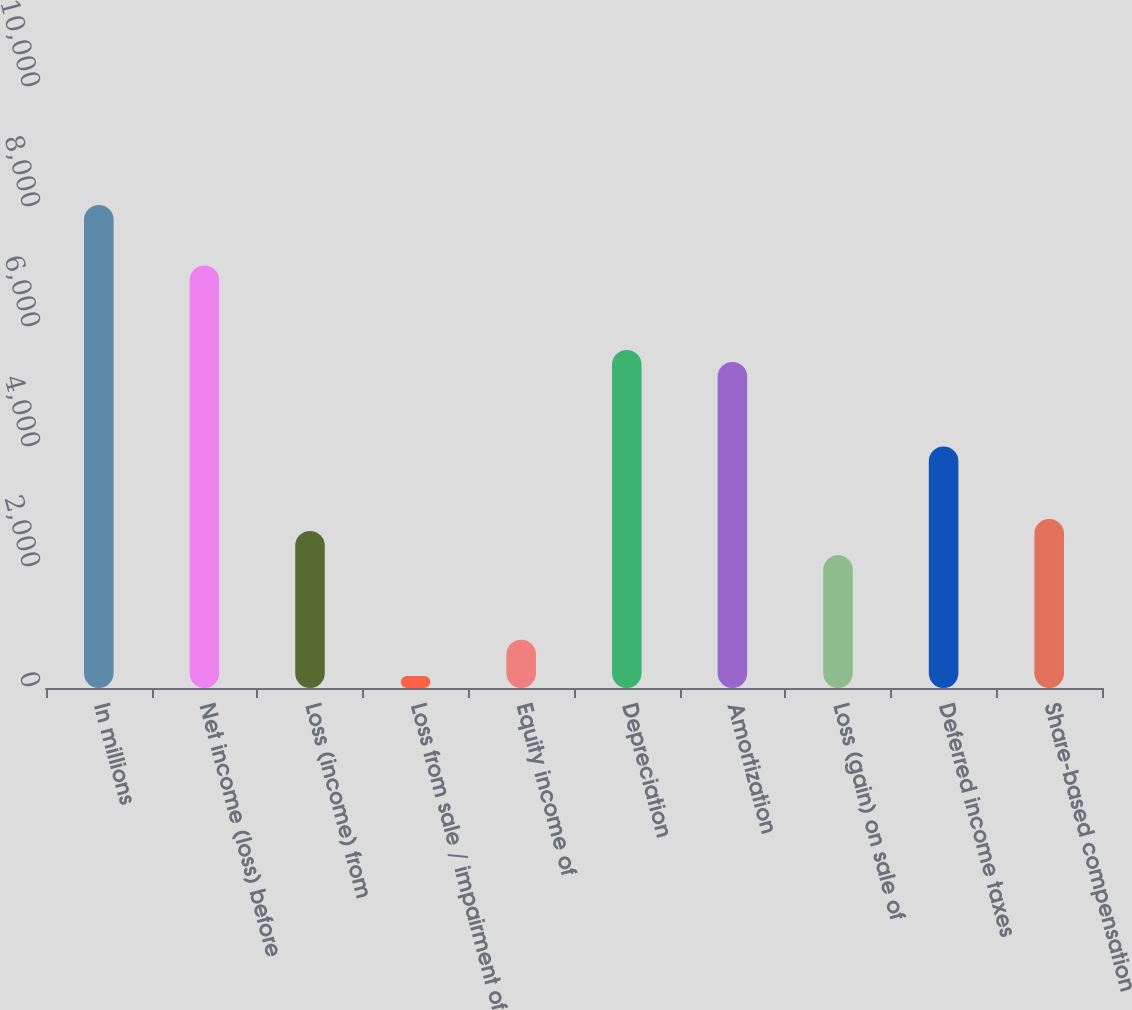Convert chart. <chart><loc_0><loc_0><loc_500><loc_500><bar_chart><fcel>In millions<fcel>Net income (loss) before<fcel>Loss (income) from<fcel>Loss from sale / impairment of<fcel>Equity income of<fcel>Depreciation<fcel>Amortization<fcel>Loss (gain) on sale of<fcel>Deferred income taxes<fcel>Share-based compensation<nl><fcel>8049.9<fcel>7043.75<fcel>2616.69<fcel>201.93<fcel>805.62<fcel>5635.14<fcel>5433.91<fcel>2214.23<fcel>4025.3<fcel>2817.92<nl></chart> 